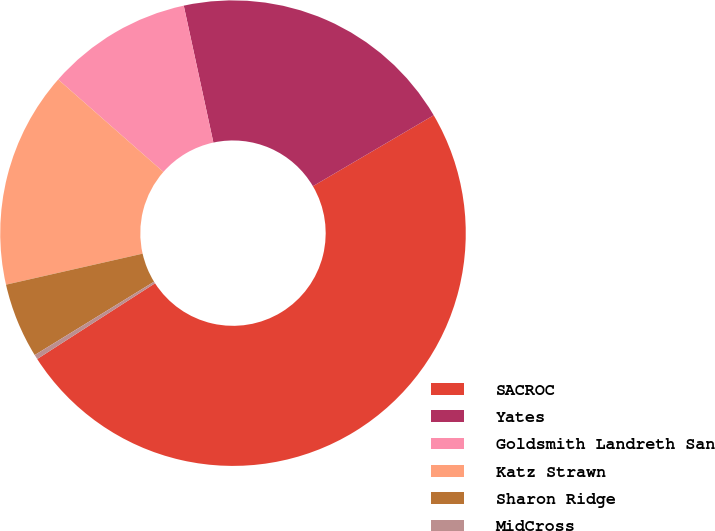Convert chart. <chart><loc_0><loc_0><loc_500><loc_500><pie_chart><fcel>SACROC<fcel>Yates<fcel>Goldsmith Landreth San<fcel>Katz Strawn<fcel>Sharon Ridge<fcel>MidCross<nl><fcel>49.36%<fcel>19.94%<fcel>10.13%<fcel>15.03%<fcel>5.22%<fcel>0.32%<nl></chart> 